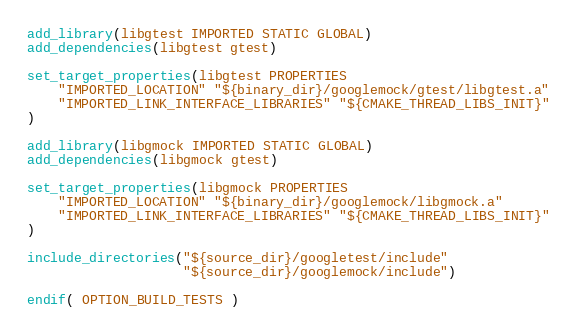Convert code to text. <code><loc_0><loc_0><loc_500><loc_500><_CMake_>add_library(libgtest IMPORTED STATIC GLOBAL)
add_dependencies(libgtest gtest)

set_target_properties(libgtest PROPERTIES
    "IMPORTED_LOCATION" "${binary_dir}/googlemock/gtest/libgtest.a"
    "IMPORTED_LINK_INTERFACE_LIBRARIES" "${CMAKE_THREAD_LIBS_INIT}"
)

add_library(libgmock IMPORTED STATIC GLOBAL)
add_dependencies(libgmock gtest)

set_target_properties(libgmock PROPERTIES
    "IMPORTED_LOCATION" "${binary_dir}/googlemock/libgmock.a"
    "IMPORTED_LINK_INTERFACE_LIBRARIES" "${CMAKE_THREAD_LIBS_INIT}"
)

include_directories("${source_dir}/googletest/include"
                    "${source_dir}/googlemock/include")

endif( OPTION_BUILD_TESTS )
</code> 